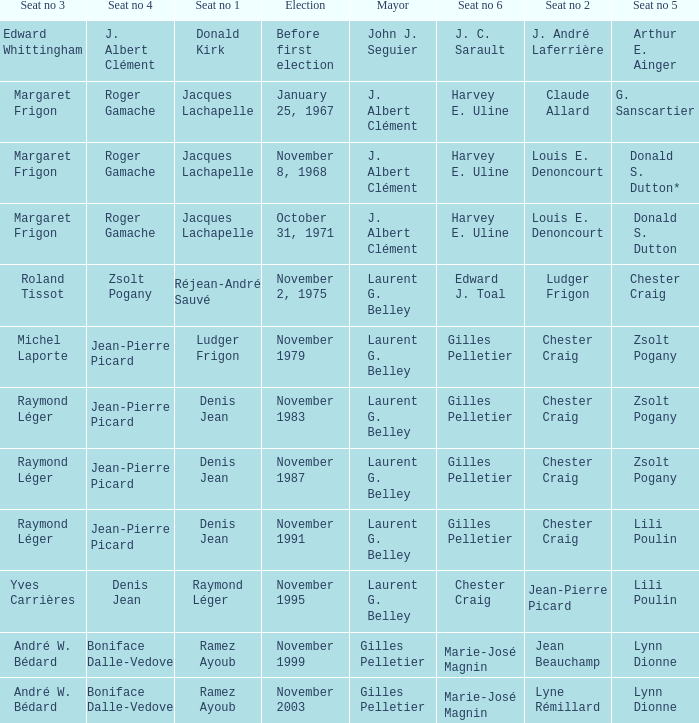Parse the table in full. {'header': ['Seat no 3', 'Seat no 4', 'Seat no 1', 'Election', 'Mayor', 'Seat no 6', 'Seat no 2', 'Seat no 5'], 'rows': [['Edward Whittingham', 'J. Albert Clément', 'Donald Kirk', 'Before first election', 'John J. Seguier', 'J. C. Sarault', 'J. André Laferrière', 'Arthur E. Ainger'], ['Margaret Frigon', 'Roger Gamache', 'Jacques Lachapelle', 'January 25, 1967', 'J. Albert Clément', 'Harvey E. Uline', 'Claude Allard', 'G. Sanscartier'], ['Margaret Frigon', 'Roger Gamache', 'Jacques Lachapelle', 'November 8, 1968', 'J. Albert Clément', 'Harvey E. Uline', 'Louis E. Denoncourt', 'Donald S. Dutton*'], ['Margaret Frigon', 'Roger Gamache', 'Jacques Lachapelle', 'October 31, 1971', 'J. Albert Clément', 'Harvey E. Uline', 'Louis E. Denoncourt', 'Donald S. Dutton'], ['Roland Tissot', 'Zsolt Pogany', 'Réjean-André Sauvé', 'November 2, 1975', 'Laurent G. Belley', 'Edward J. Toal', 'Ludger Frigon', 'Chester Craig'], ['Michel Laporte', 'Jean-Pierre Picard', 'Ludger Frigon', 'November 1979', 'Laurent G. Belley', 'Gilles Pelletier', 'Chester Craig', 'Zsolt Pogany'], ['Raymond Léger', 'Jean-Pierre Picard', 'Denis Jean', 'November 1983', 'Laurent G. Belley', 'Gilles Pelletier', 'Chester Craig', 'Zsolt Pogany'], ['Raymond Léger', 'Jean-Pierre Picard', 'Denis Jean', 'November 1987', 'Laurent G. Belley', 'Gilles Pelletier', 'Chester Craig', 'Zsolt Pogany'], ['Raymond Léger', 'Jean-Pierre Picard', 'Denis Jean', 'November 1991', 'Laurent G. Belley', 'Gilles Pelletier', 'Chester Craig', 'Lili Poulin'], ['Yves Carrières', 'Denis Jean', 'Raymond Léger', 'November 1995', 'Laurent G. Belley', 'Chester Craig', 'Jean-Pierre Picard', 'Lili Poulin'], ['André W. Bédard', 'Boniface Dalle-Vedove', 'Ramez Ayoub', 'November 1999', 'Gilles Pelletier', 'Marie-José Magnin', 'Jean Beauchamp', 'Lynn Dionne'], ['André W. Bédard', 'Boniface Dalle-Vedove', 'Ramez Ayoub', 'November 2003', 'Gilles Pelletier', 'Marie-José Magnin', 'Lyne Rémillard', 'Lynn Dionne']]} Who was the winner of seat no 4 for the election on January 25, 1967 Roger Gamache. 